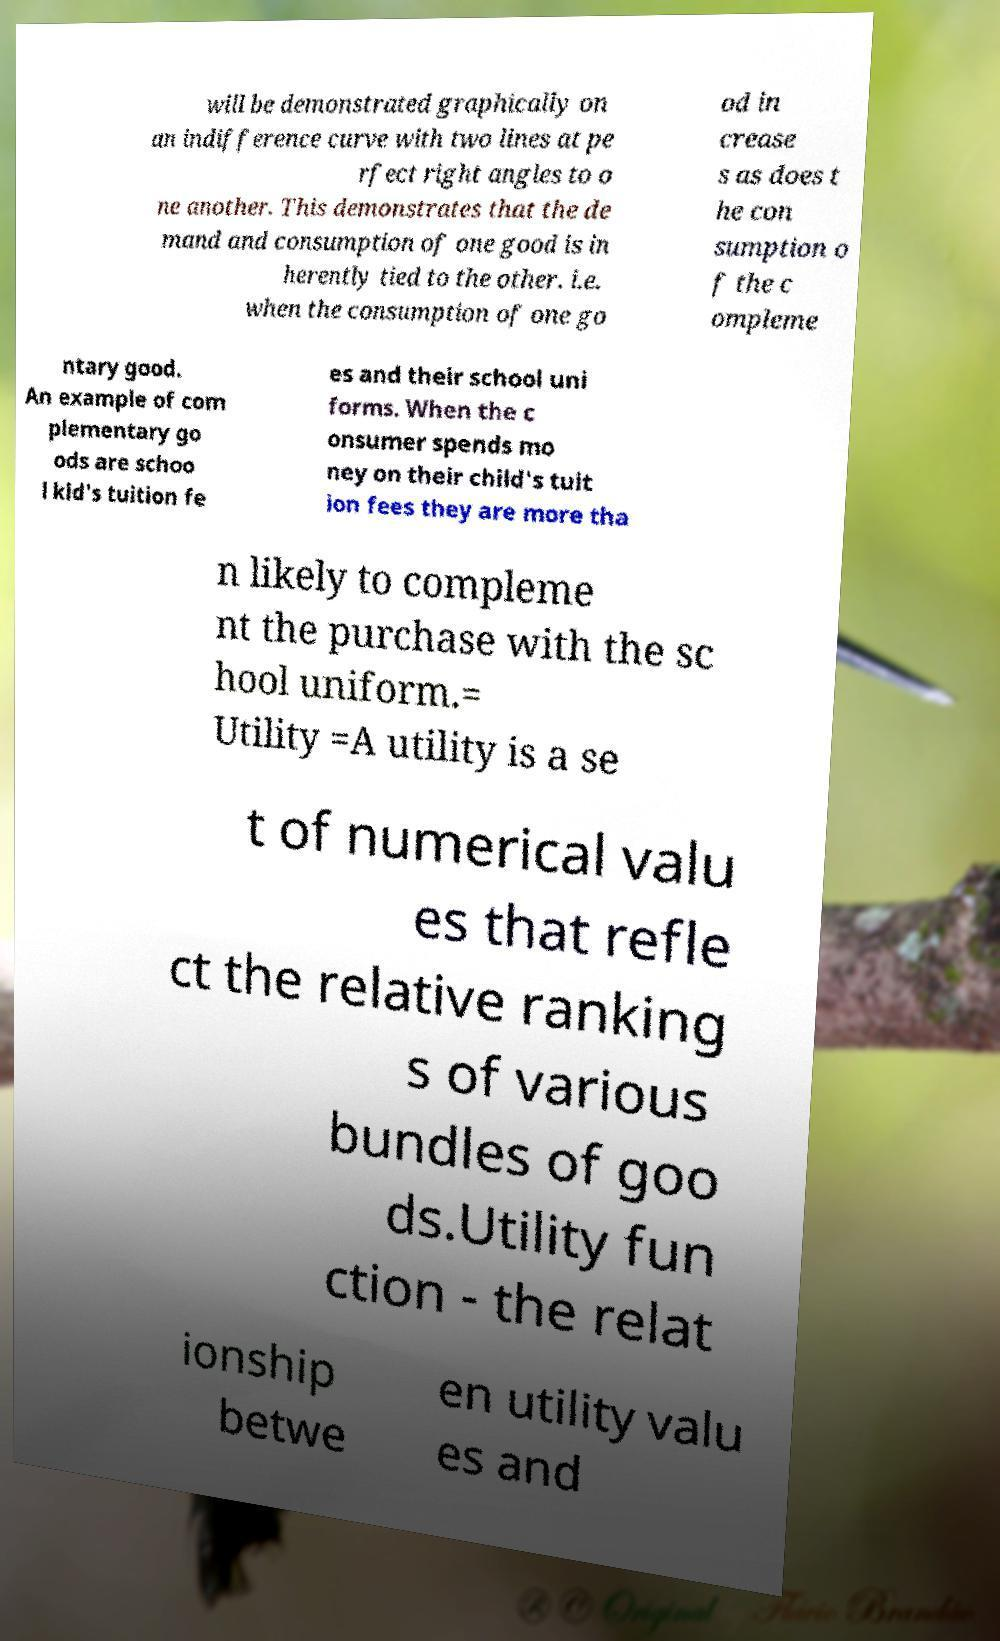Please read and relay the text visible in this image. What does it say? will be demonstrated graphically on an indifference curve with two lines at pe rfect right angles to o ne another. This demonstrates that the de mand and consumption of one good is in herently tied to the other. i.e. when the consumption of one go od in crease s as does t he con sumption o f the c ompleme ntary good. An example of com plementary go ods are schoo l kid's tuition fe es and their school uni forms. When the c onsumer spends mo ney on their child's tuit ion fees they are more tha n likely to compleme nt the purchase with the sc hool uniform.= Utility =A utility is a se t of numerical valu es that refle ct the relative ranking s of various bundles of goo ds.Utility fun ction - the relat ionship betwe en utility valu es and 